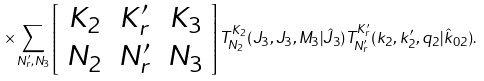<formula> <loc_0><loc_0><loc_500><loc_500>\times \sum _ { N ^ { \prime } _ { r } , N _ { 3 } } \left [ \begin{array} { c c c } K _ { 2 } & K ^ { \prime } _ { r } & K _ { 3 } \\ N _ { 2 } & N ^ { \prime } _ { r } & N _ { 3 } \end{array} \right ] T ^ { K _ { 2 } } _ { N _ { 2 } } ( J _ { 3 } , J _ { 3 } , M _ { 3 } | \hat { J } _ { 3 } ) T ^ { K ^ { \prime } _ { r } } _ { N ^ { \prime } _ { r } } ( k _ { 2 } , k ^ { \prime } _ { 2 } , q _ { 2 } | \hat { k } _ { 0 2 } ) .</formula> 